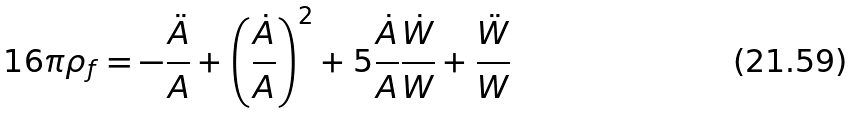<formula> <loc_0><loc_0><loc_500><loc_500>1 6 \pi \rho _ { f } = - \frac { \ddot { A } } { A } + \left ( \frac { \dot { A } } { A } \right ) ^ { 2 } + 5 \frac { \dot { A } } { A } \frac { \dot { W } } { W } + \frac { \ddot { W } } { W }</formula> 